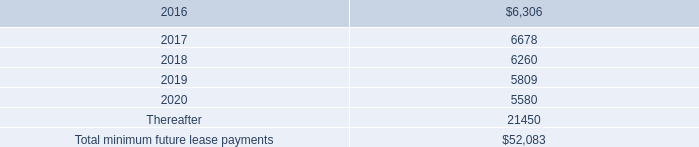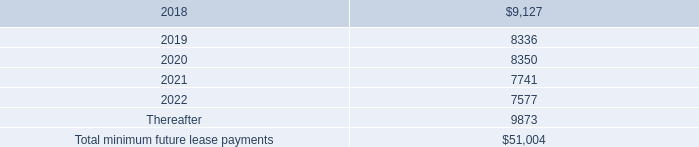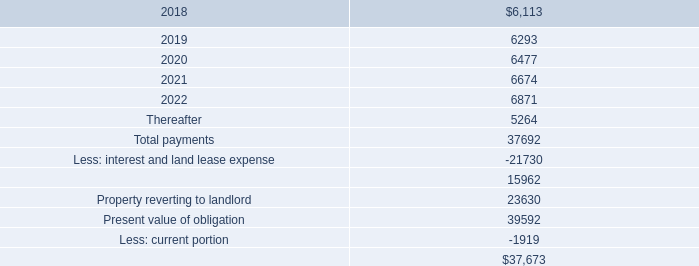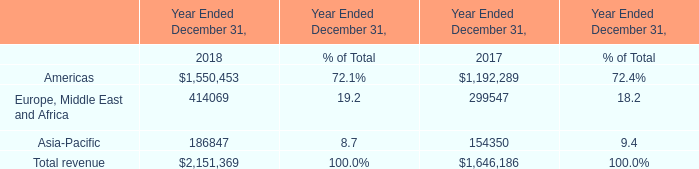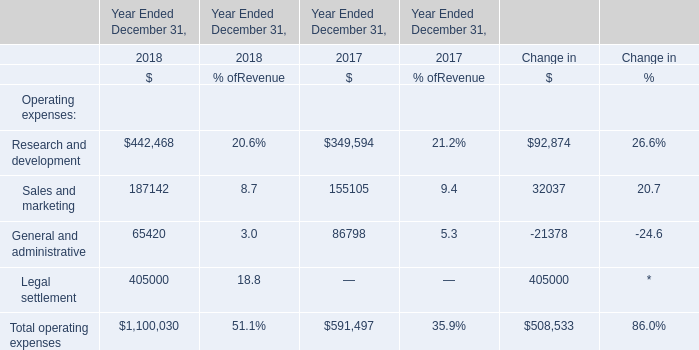In what year is the amount of Sales and marketing positive? 
Answer: 2018. 